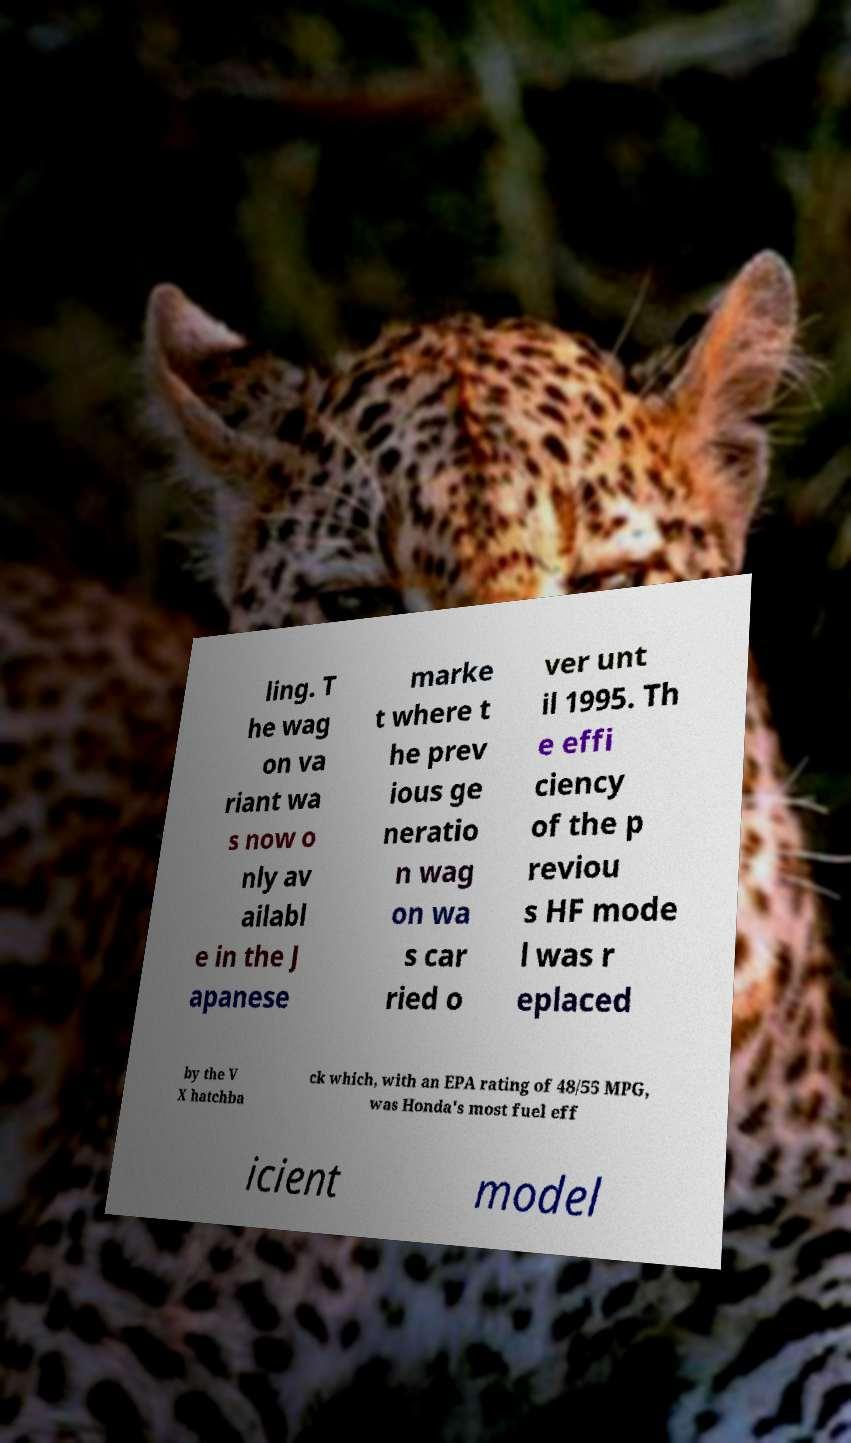Please read and relay the text visible in this image. What does it say? ling. T he wag on va riant wa s now o nly av ailabl e in the J apanese marke t where t he prev ious ge neratio n wag on wa s car ried o ver unt il 1995. Th e effi ciency of the p reviou s HF mode l was r eplaced by the V X hatchba ck which, with an EPA rating of 48/55 MPG, was Honda's most fuel eff icient model 